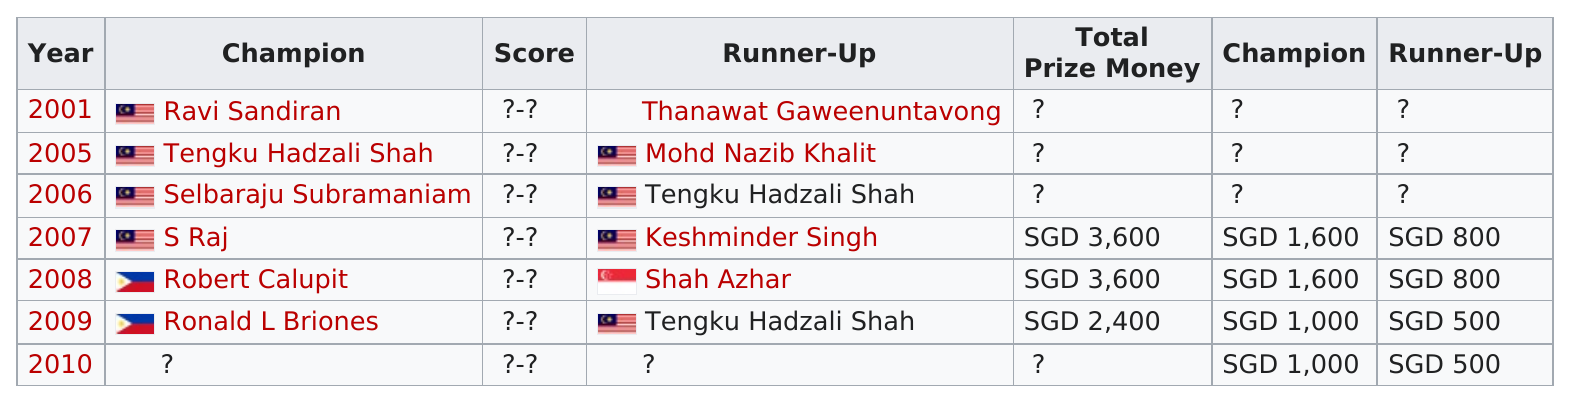Point out several critical features in this image. Selbaraju Subramaniam was the champion previous to S Raj. It has been several years since we have had a runner-up. The person who is next after S. Raj is Robert Calupit. According to the information provided, Raj earned more money than Keshminder Singh in the 2007 open by 800. The total number of champions for Ronald L. Briones is 1. 